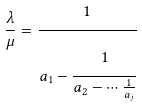Convert formula to latex. <formula><loc_0><loc_0><loc_500><loc_500>\frac { \lambda } { \mu } = \cfrac { 1 } { a _ { 1 } - \cfrac { 1 } { a _ { 2 } - \cdots \frac { 1 } { a _ { j } } } }</formula> 